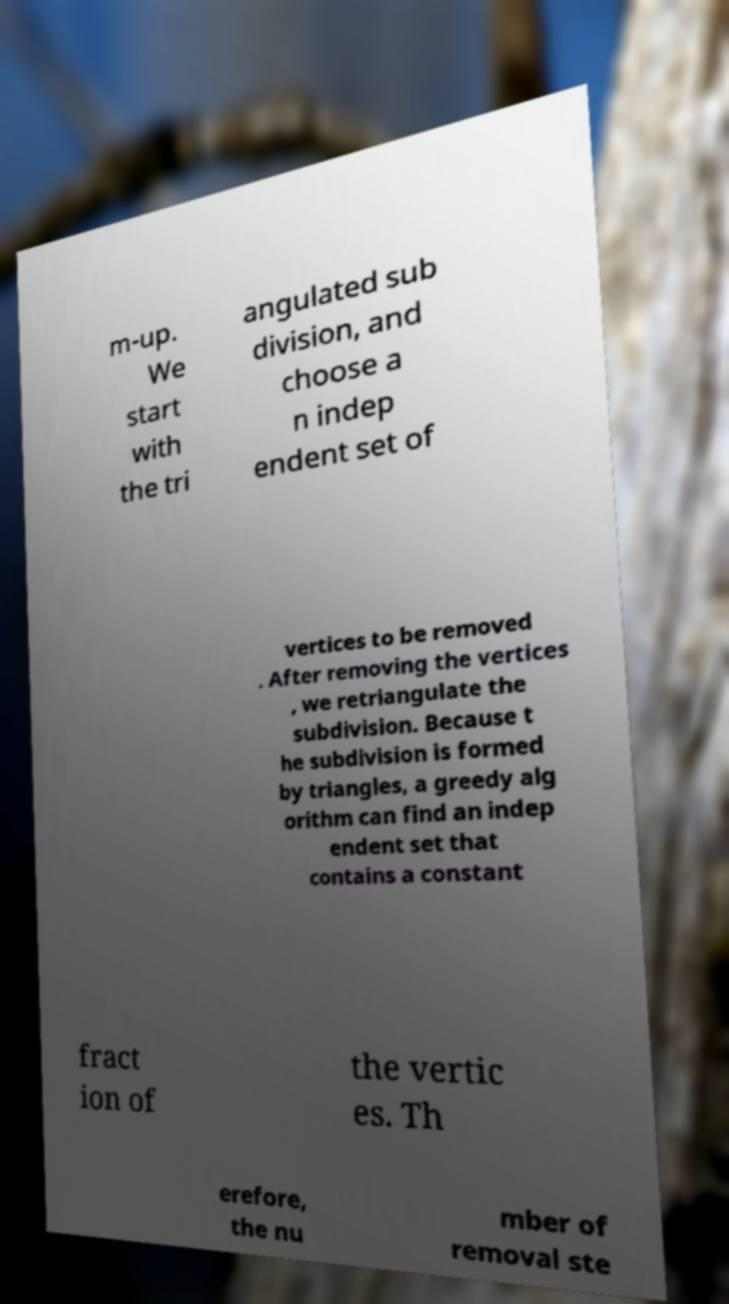Can you accurately transcribe the text from the provided image for me? m-up. We start with the tri angulated sub division, and choose a n indep endent set of vertices to be removed . After removing the vertices , we retriangulate the subdivision. Because t he subdivision is formed by triangles, a greedy alg orithm can find an indep endent set that contains a constant fract ion of the vertic es. Th erefore, the nu mber of removal ste 